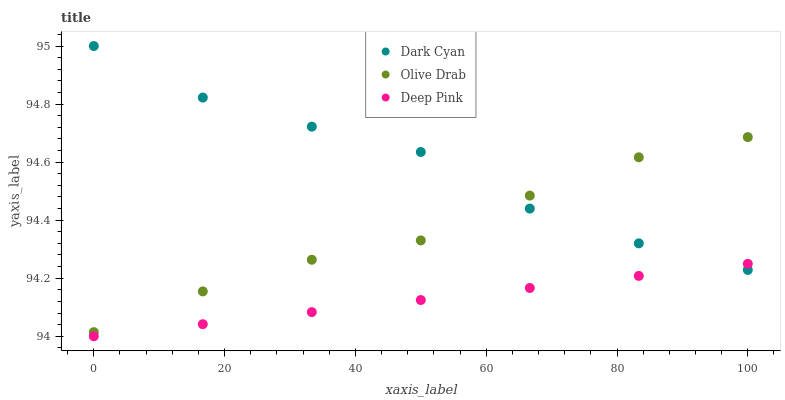Does Deep Pink have the minimum area under the curve?
Answer yes or no. Yes. Does Dark Cyan have the maximum area under the curve?
Answer yes or no. Yes. Does Olive Drab have the minimum area under the curve?
Answer yes or no. No. Does Olive Drab have the maximum area under the curve?
Answer yes or no. No. Is Deep Pink the smoothest?
Answer yes or no. Yes. Is Dark Cyan the roughest?
Answer yes or no. Yes. Is Olive Drab the smoothest?
Answer yes or no. No. Is Olive Drab the roughest?
Answer yes or no. No. Does Deep Pink have the lowest value?
Answer yes or no. Yes. Does Olive Drab have the lowest value?
Answer yes or no. No. Does Dark Cyan have the highest value?
Answer yes or no. Yes. Does Olive Drab have the highest value?
Answer yes or no. No. Is Deep Pink less than Olive Drab?
Answer yes or no. Yes. Is Olive Drab greater than Deep Pink?
Answer yes or no. Yes. Does Deep Pink intersect Dark Cyan?
Answer yes or no. Yes. Is Deep Pink less than Dark Cyan?
Answer yes or no. No. Is Deep Pink greater than Dark Cyan?
Answer yes or no. No. Does Deep Pink intersect Olive Drab?
Answer yes or no. No. 